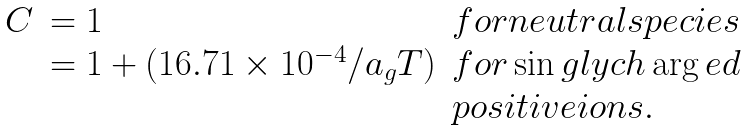<formula> <loc_0><loc_0><loc_500><loc_500>\begin{array} { l l l } C & = 1 & f o r n e u t r a l s p e c i e s \\ & = 1 + ( 1 6 . 7 1 \times 1 0 ^ { - 4 } / a _ { g } T ) & f o r \sin g l y c h \arg e d \\ & & p o s i t i v e i o n s . \end{array}</formula> 